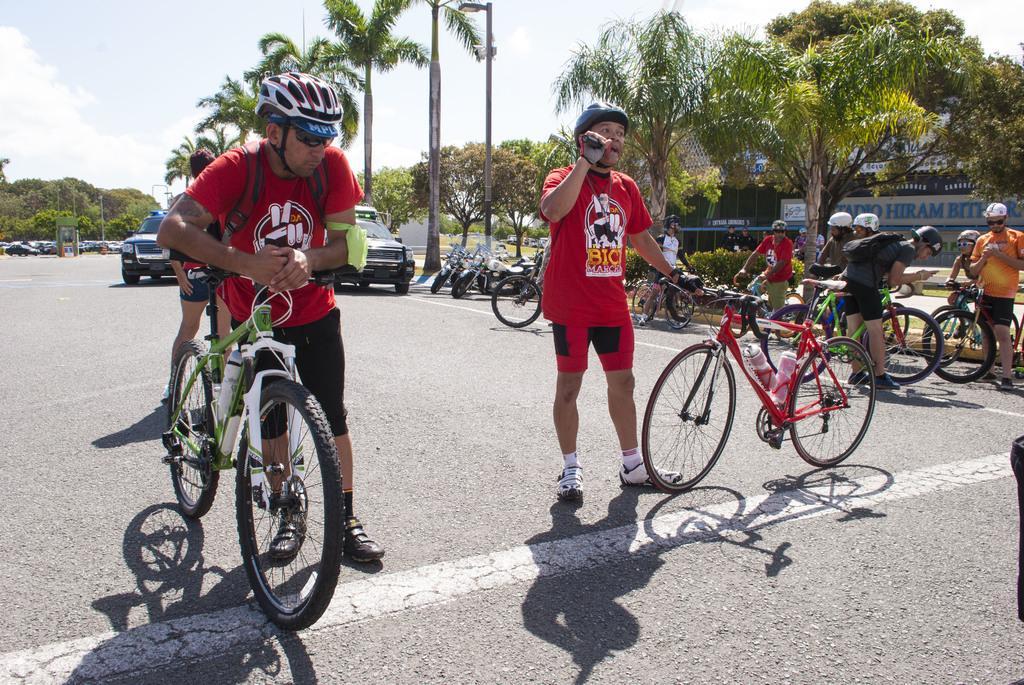Describe this image in one or two sentences. At the top of the picture we can see a sky with clouds and it seems like a sunny day. These are trees. Here we can see few vehicles on the road. Here we can see few men holding bicycles with their hands on the road. This is a hoarding. 